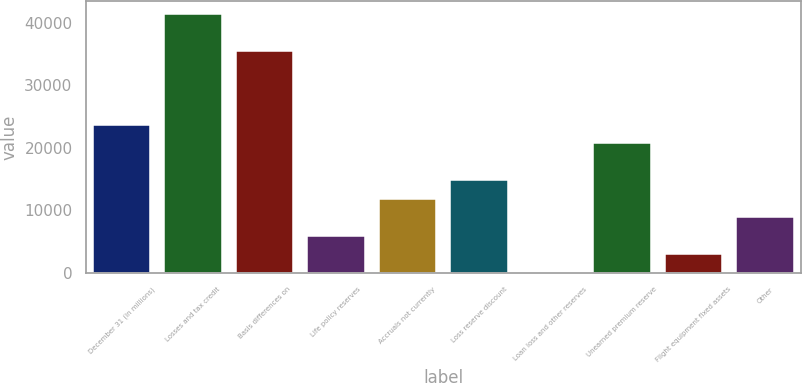Convert chart to OTSL. <chart><loc_0><loc_0><loc_500><loc_500><bar_chart><fcel>December 31 (in millions)<fcel>Losses and tax credit<fcel>Basis differences on<fcel>Life policy reserves<fcel>Accruals not currently<fcel>Loss reserve discount<fcel>Loan loss and other reserves<fcel>Unearned premium reserve<fcel>Flight equipment fixed assets<fcel>Other<nl><fcel>23638.4<fcel>41361.2<fcel>35453.6<fcel>5915.6<fcel>11823.2<fcel>14777<fcel>8<fcel>20684.6<fcel>2961.8<fcel>8869.4<nl></chart> 